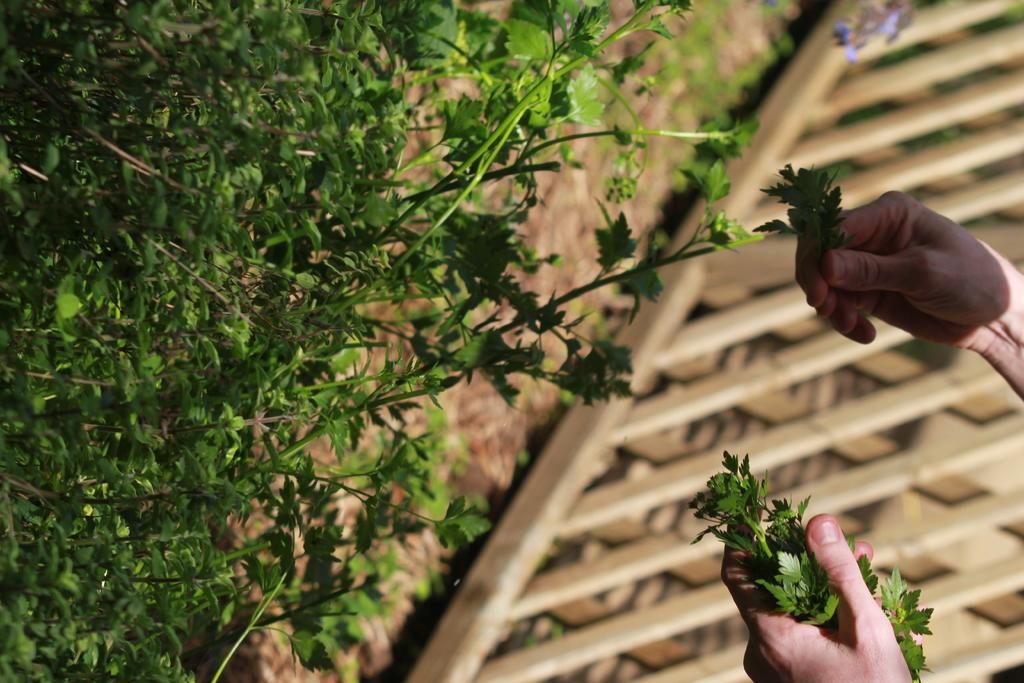What type of plant is in the image? There is a coriander plant in the image. Can you describe the person in the image? A person is standing in the image. What is the person doing in the image? The person is plucking coriander leaves. What type of government is depicted in the image? There is no depiction of a government in the image; it features a person plucking coriander leaves from a coriander plant. How many clouds are visible in the image? There are no clouds visible in the image; it is focused on the coriander plant and the person plucking leaves. 